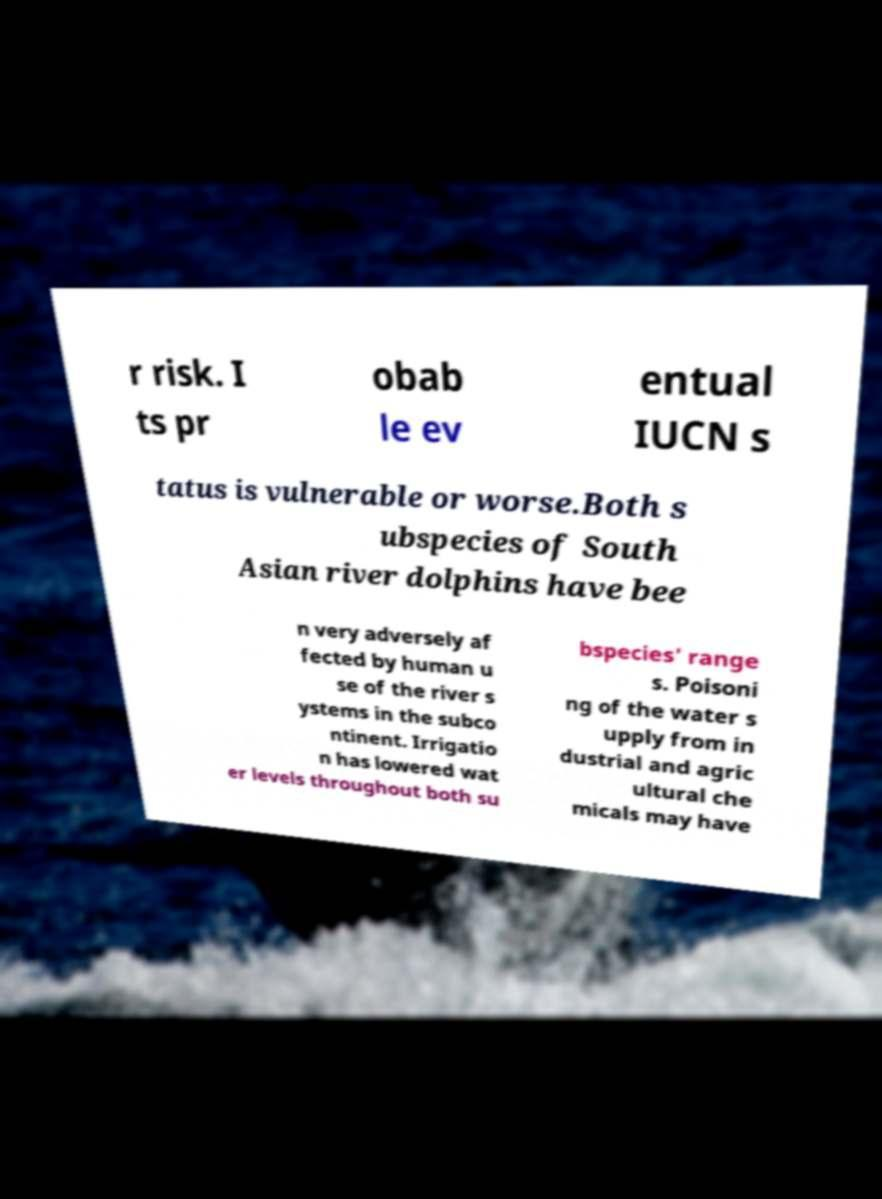Could you extract and type out the text from this image? r risk. I ts pr obab le ev entual IUCN s tatus is vulnerable or worse.Both s ubspecies of South Asian river dolphins have bee n very adversely af fected by human u se of the river s ystems in the subco ntinent. Irrigatio n has lowered wat er levels throughout both su bspecies' range s. Poisoni ng of the water s upply from in dustrial and agric ultural che micals may have 